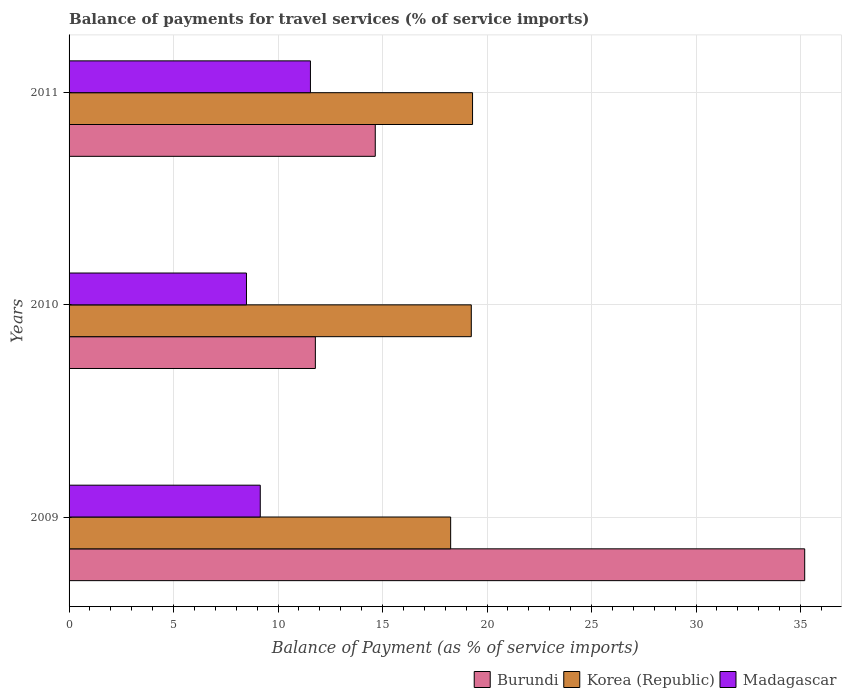How many different coloured bars are there?
Your answer should be compact. 3. How many groups of bars are there?
Your response must be concise. 3. Are the number of bars per tick equal to the number of legend labels?
Make the answer very short. Yes. How many bars are there on the 3rd tick from the bottom?
Your answer should be very brief. 3. In how many cases, is the number of bars for a given year not equal to the number of legend labels?
Keep it short and to the point. 0. What is the balance of payments for travel services in Madagascar in 2011?
Give a very brief answer. 11.55. Across all years, what is the maximum balance of payments for travel services in Madagascar?
Ensure brevity in your answer.  11.55. Across all years, what is the minimum balance of payments for travel services in Madagascar?
Offer a very short reply. 8.49. What is the total balance of payments for travel services in Burundi in the graph?
Make the answer very short. 61.64. What is the difference between the balance of payments for travel services in Burundi in 2009 and that in 2010?
Your answer should be very brief. 23.42. What is the difference between the balance of payments for travel services in Madagascar in 2010 and the balance of payments for travel services in Korea (Republic) in 2011?
Offer a very short reply. -10.82. What is the average balance of payments for travel services in Korea (Republic) per year?
Provide a succinct answer. 18.94. In the year 2011, what is the difference between the balance of payments for travel services in Korea (Republic) and balance of payments for travel services in Madagascar?
Ensure brevity in your answer.  7.76. In how many years, is the balance of payments for travel services in Burundi greater than 29 %?
Ensure brevity in your answer.  1. What is the ratio of the balance of payments for travel services in Burundi in 2009 to that in 2011?
Your answer should be very brief. 2.4. Is the balance of payments for travel services in Burundi in 2010 less than that in 2011?
Provide a short and direct response. Yes. Is the difference between the balance of payments for travel services in Korea (Republic) in 2009 and 2010 greater than the difference between the balance of payments for travel services in Madagascar in 2009 and 2010?
Offer a terse response. No. What is the difference between the highest and the second highest balance of payments for travel services in Madagascar?
Offer a terse response. 2.4. What is the difference between the highest and the lowest balance of payments for travel services in Burundi?
Offer a terse response. 23.42. Is the sum of the balance of payments for travel services in Burundi in 2009 and 2011 greater than the maximum balance of payments for travel services in Korea (Republic) across all years?
Make the answer very short. Yes. What does the 3rd bar from the top in 2009 represents?
Make the answer very short. Burundi. What does the 3rd bar from the bottom in 2009 represents?
Your answer should be very brief. Madagascar. Is it the case that in every year, the sum of the balance of payments for travel services in Madagascar and balance of payments for travel services in Burundi is greater than the balance of payments for travel services in Korea (Republic)?
Offer a terse response. Yes. How many bars are there?
Offer a very short reply. 9. Are all the bars in the graph horizontal?
Your answer should be compact. Yes. How many years are there in the graph?
Provide a succinct answer. 3. What is the difference between two consecutive major ticks on the X-axis?
Give a very brief answer. 5. Does the graph contain grids?
Your answer should be very brief. Yes. What is the title of the graph?
Offer a terse response. Balance of payments for travel services (% of service imports). What is the label or title of the X-axis?
Provide a succinct answer. Balance of Payment (as % of service imports). What is the label or title of the Y-axis?
Make the answer very short. Years. What is the Balance of Payment (as % of service imports) in Burundi in 2009?
Keep it short and to the point. 35.2. What is the Balance of Payment (as % of service imports) in Korea (Republic) in 2009?
Your answer should be compact. 18.26. What is the Balance of Payment (as % of service imports) of Madagascar in 2009?
Give a very brief answer. 9.15. What is the Balance of Payment (as % of service imports) of Burundi in 2010?
Your answer should be very brief. 11.79. What is the Balance of Payment (as % of service imports) in Korea (Republic) in 2010?
Provide a short and direct response. 19.25. What is the Balance of Payment (as % of service imports) in Madagascar in 2010?
Provide a succinct answer. 8.49. What is the Balance of Payment (as % of service imports) of Burundi in 2011?
Keep it short and to the point. 14.65. What is the Balance of Payment (as % of service imports) in Korea (Republic) in 2011?
Your response must be concise. 19.31. What is the Balance of Payment (as % of service imports) in Madagascar in 2011?
Offer a very short reply. 11.55. Across all years, what is the maximum Balance of Payment (as % of service imports) in Burundi?
Make the answer very short. 35.2. Across all years, what is the maximum Balance of Payment (as % of service imports) in Korea (Republic)?
Offer a terse response. 19.31. Across all years, what is the maximum Balance of Payment (as % of service imports) in Madagascar?
Offer a terse response. 11.55. Across all years, what is the minimum Balance of Payment (as % of service imports) in Burundi?
Provide a succinct answer. 11.79. Across all years, what is the minimum Balance of Payment (as % of service imports) of Korea (Republic)?
Your answer should be compact. 18.26. Across all years, what is the minimum Balance of Payment (as % of service imports) of Madagascar?
Your answer should be very brief. 8.49. What is the total Balance of Payment (as % of service imports) in Burundi in the graph?
Your answer should be very brief. 61.64. What is the total Balance of Payment (as % of service imports) in Korea (Republic) in the graph?
Offer a terse response. 56.81. What is the total Balance of Payment (as % of service imports) of Madagascar in the graph?
Keep it short and to the point. 29.19. What is the difference between the Balance of Payment (as % of service imports) of Burundi in 2009 and that in 2010?
Your answer should be compact. 23.42. What is the difference between the Balance of Payment (as % of service imports) of Korea (Republic) in 2009 and that in 2010?
Keep it short and to the point. -0.99. What is the difference between the Balance of Payment (as % of service imports) in Madagascar in 2009 and that in 2010?
Provide a short and direct response. 0.66. What is the difference between the Balance of Payment (as % of service imports) of Burundi in 2009 and that in 2011?
Provide a short and direct response. 20.55. What is the difference between the Balance of Payment (as % of service imports) of Korea (Republic) in 2009 and that in 2011?
Offer a terse response. -1.05. What is the difference between the Balance of Payment (as % of service imports) in Madagascar in 2009 and that in 2011?
Your answer should be compact. -2.4. What is the difference between the Balance of Payment (as % of service imports) in Burundi in 2010 and that in 2011?
Your answer should be compact. -2.87. What is the difference between the Balance of Payment (as % of service imports) in Korea (Republic) in 2010 and that in 2011?
Your answer should be compact. -0.06. What is the difference between the Balance of Payment (as % of service imports) of Madagascar in 2010 and that in 2011?
Ensure brevity in your answer.  -3.06. What is the difference between the Balance of Payment (as % of service imports) in Burundi in 2009 and the Balance of Payment (as % of service imports) in Korea (Republic) in 2010?
Provide a succinct answer. 15.95. What is the difference between the Balance of Payment (as % of service imports) in Burundi in 2009 and the Balance of Payment (as % of service imports) in Madagascar in 2010?
Provide a short and direct response. 26.71. What is the difference between the Balance of Payment (as % of service imports) in Korea (Republic) in 2009 and the Balance of Payment (as % of service imports) in Madagascar in 2010?
Offer a very short reply. 9.77. What is the difference between the Balance of Payment (as % of service imports) in Burundi in 2009 and the Balance of Payment (as % of service imports) in Korea (Republic) in 2011?
Your answer should be very brief. 15.89. What is the difference between the Balance of Payment (as % of service imports) in Burundi in 2009 and the Balance of Payment (as % of service imports) in Madagascar in 2011?
Ensure brevity in your answer.  23.65. What is the difference between the Balance of Payment (as % of service imports) in Korea (Republic) in 2009 and the Balance of Payment (as % of service imports) in Madagascar in 2011?
Provide a succinct answer. 6.71. What is the difference between the Balance of Payment (as % of service imports) of Burundi in 2010 and the Balance of Payment (as % of service imports) of Korea (Republic) in 2011?
Ensure brevity in your answer.  -7.52. What is the difference between the Balance of Payment (as % of service imports) in Burundi in 2010 and the Balance of Payment (as % of service imports) in Madagascar in 2011?
Make the answer very short. 0.24. What is the difference between the Balance of Payment (as % of service imports) of Korea (Republic) in 2010 and the Balance of Payment (as % of service imports) of Madagascar in 2011?
Offer a very short reply. 7.7. What is the average Balance of Payment (as % of service imports) of Burundi per year?
Ensure brevity in your answer.  20.55. What is the average Balance of Payment (as % of service imports) of Korea (Republic) per year?
Offer a terse response. 18.94. What is the average Balance of Payment (as % of service imports) in Madagascar per year?
Offer a terse response. 9.73. In the year 2009, what is the difference between the Balance of Payment (as % of service imports) in Burundi and Balance of Payment (as % of service imports) in Korea (Republic)?
Your answer should be compact. 16.94. In the year 2009, what is the difference between the Balance of Payment (as % of service imports) of Burundi and Balance of Payment (as % of service imports) of Madagascar?
Keep it short and to the point. 26.05. In the year 2009, what is the difference between the Balance of Payment (as % of service imports) of Korea (Republic) and Balance of Payment (as % of service imports) of Madagascar?
Make the answer very short. 9.11. In the year 2010, what is the difference between the Balance of Payment (as % of service imports) of Burundi and Balance of Payment (as % of service imports) of Korea (Republic)?
Keep it short and to the point. -7.46. In the year 2010, what is the difference between the Balance of Payment (as % of service imports) of Burundi and Balance of Payment (as % of service imports) of Madagascar?
Your answer should be compact. 3.3. In the year 2010, what is the difference between the Balance of Payment (as % of service imports) in Korea (Republic) and Balance of Payment (as % of service imports) in Madagascar?
Offer a terse response. 10.76. In the year 2011, what is the difference between the Balance of Payment (as % of service imports) in Burundi and Balance of Payment (as % of service imports) in Korea (Republic)?
Offer a very short reply. -4.66. In the year 2011, what is the difference between the Balance of Payment (as % of service imports) of Burundi and Balance of Payment (as % of service imports) of Madagascar?
Provide a short and direct response. 3.1. In the year 2011, what is the difference between the Balance of Payment (as % of service imports) in Korea (Republic) and Balance of Payment (as % of service imports) in Madagascar?
Your answer should be very brief. 7.76. What is the ratio of the Balance of Payment (as % of service imports) in Burundi in 2009 to that in 2010?
Your response must be concise. 2.99. What is the ratio of the Balance of Payment (as % of service imports) of Korea (Republic) in 2009 to that in 2010?
Make the answer very short. 0.95. What is the ratio of the Balance of Payment (as % of service imports) in Madagascar in 2009 to that in 2010?
Offer a very short reply. 1.08. What is the ratio of the Balance of Payment (as % of service imports) in Burundi in 2009 to that in 2011?
Make the answer very short. 2.4. What is the ratio of the Balance of Payment (as % of service imports) in Korea (Republic) in 2009 to that in 2011?
Provide a short and direct response. 0.95. What is the ratio of the Balance of Payment (as % of service imports) in Madagascar in 2009 to that in 2011?
Provide a short and direct response. 0.79. What is the ratio of the Balance of Payment (as % of service imports) of Burundi in 2010 to that in 2011?
Provide a short and direct response. 0.8. What is the ratio of the Balance of Payment (as % of service imports) in Korea (Republic) in 2010 to that in 2011?
Offer a terse response. 1. What is the ratio of the Balance of Payment (as % of service imports) in Madagascar in 2010 to that in 2011?
Your answer should be very brief. 0.73. What is the difference between the highest and the second highest Balance of Payment (as % of service imports) of Burundi?
Offer a terse response. 20.55. What is the difference between the highest and the second highest Balance of Payment (as % of service imports) in Korea (Republic)?
Your response must be concise. 0.06. What is the difference between the highest and the second highest Balance of Payment (as % of service imports) in Madagascar?
Provide a short and direct response. 2.4. What is the difference between the highest and the lowest Balance of Payment (as % of service imports) of Burundi?
Offer a very short reply. 23.42. What is the difference between the highest and the lowest Balance of Payment (as % of service imports) of Korea (Republic)?
Make the answer very short. 1.05. What is the difference between the highest and the lowest Balance of Payment (as % of service imports) in Madagascar?
Ensure brevity in your answer.  3.06. 